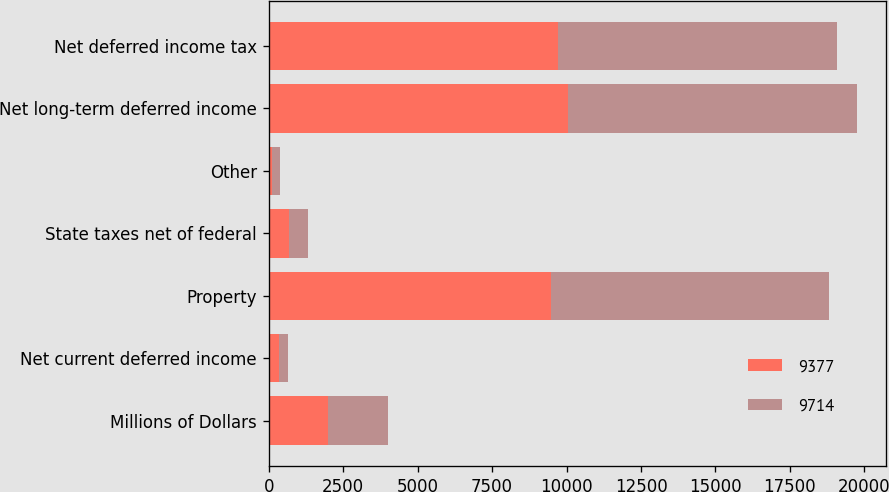Convert chart. <chart><loc_0><loc_0><loc_500><loc_500><stacked_bar_chart><ecel><fcel>Millions of Dollars<fcel>Net current deferred income<fcel>Property<fcel>State taxes net of federal<fcel>Other<fcel>Net long-term deferred income<fcel>Net deferred income tax<nl><fcel>9377<fcel>2007<fcel>336<fcel>9467<fcel>691<fcel>108<fcel>10050<fcel>9714<nl><fcel>9714<fcel>2006<fcel>319<fcel>9356<fcel>617<fcel>277<fcel>9696<fcel>9377<nl></chart> 